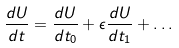<formula> <loc_0><loc_0><loc_500><loc_500>\frac { d U } { d t } = \frac { d U } { d t _ { 0 } } + \epsilon \frac { d U } { d t _ { 1 } } + \dots</formula> 